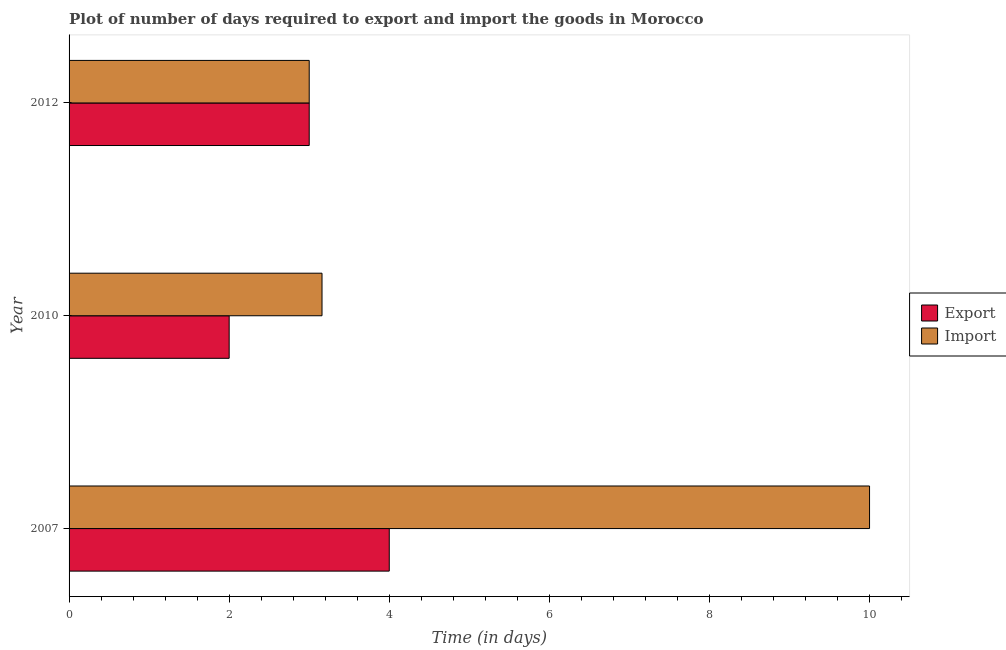Are the number of bars per tick equal to the number of legend labels?
Offer a very short reply. Yes. Are the number of bars on each tick of the Y-axis equal?
Offer a very short reply. Yes. How many bars are there on the 1st tick from the top?
Ensure brevity in your answer.  2. How many bars are there on the 2nd tick from the bottom?
Offer a terse response. 2. What is the time required to import in 2010?
Ensure brevity in your answer.  3.16. What is the total time required to import in the graph?
Give a very brief answer. 16.16. What is the difference between the time required to import in 2010 and that in 2012?
Ensure brevity in your answer.  0.16. What is the difference between the time required to import in 2010 and the time required to export in 2007?
Your answer should be compact. -0.84. What is the average time required to import per year?
Offer a very short reply. 5.39. In the year 2010, what is the difference between the time required to import and time required to export?
Offer a terse response. 1.16. What is the ratio of the time required to export in 2007 to that in 2012?
Keep it short and to the point. 1.33. Is the difference between the time required to import in 2010 and 2012 greater than the difference between the time required to export in 2010 and 2012?
Make the answer very short. Yes. What is the difference between the highest and the second highest time required to import?
Give a very brief answer. 6.84. What is the difference between the highest and the lowest time required to export?
Keep it short and to the point. 2. Is the sum of the time required to import in 2007 and 2010 greater than the maximum time required to export across all years?
Give a very brief answer. Yes. What does the 2nd bar from the top in 2010 represents?
Offer a terse response. Export. What does the 2nd bar from the bottom in 2010 represents?
Offer a terse response. Import. How many bars are there?
Give a very brief answer. 6. Are all the bars in the graph horizontal?
Ensure brevity in your answer.  Yes. How many years are there in the graph?
Provide a succinct answer. 3. Does the graph contain grids?
Keep it short and to the point. No. What is the title of the graph?
Ensure brevity in your answer.  Plot of number of days required to export and import the goods in Morocco. Does "current US$" appear as one of the legend labels in the graph?
Keep it short and to the point. No. What is the label or title of the X-axis?
Keep it short and to the point. Time (in days). What is the Time (in days) in Import in 2010?
Ensure brevity in your answer.  3.16. What is the Time (in days) in Import in 2012?
Your answer should be very brief. 3. Across all years, what is the maximum Time (in days) in Export?
Your response must be concise. 4. Across all years, what is the maximum Time (in days) of Import?
Keep it short and to the point. 10. Across all years, what is the minimum Time (in days) of Export?
Offer a terse response. 2. What is the total Time (in days) of Import in the graph?
Provide a short and direct response. 16.16. What is the difference between the Time (in days) in Import in 2007 and that in 2010?
Your answer should be compact. 6.84. What is the difference between the Time (in days) of Export in 2007 and that in 2012?
Your answer should be very brief. 1. What is the difference between the Time (in days) in Import in 2010 and that in 2012?
Keep it short and to the point. 0.16. What is the difference between the Time (in days) of Export in 2007 and the Time (in days) of Import in 2010?
Provide a succinct answer. 0.84. What is the difference between the Time (in days) in Export in 2007 and the Time (in days) in Import in 2012?
Ensure brevity in your answer.  1. What is the average Time (in days) of Export per year?
Make the answer very short. 3. What is the average Time (in days) of Import per year?
Make the answer very short. 5.39. In the year 2007, what is the difference between the Time (in days) of Export and Time (in days) of Import?
Make the answer very short. -6. In the year 2010, what is the difference between the Time (in days) of Export and Time (in days) of Import?
Offer a terse response. -1.16. What is the ratio of the Time (in days) in Export in 2007 to that in 2010?
Provide a succinct answer. 2. What is the ratio of the Time (in days) of Import in 2007 to that in 2010?
Offer a very short reply. 3.16. What is the ratio of the Time (in days) of Export in 2007 to that in 2012?
Give a very brief answer. 1.33. What is the ratio of the Time (in days) of Import in 2010 to that in 2012?
Make the answer very short. 1.05. What is the difference between the highest and the second highest Time (in days) of Import?
Your answer should be compact. 6.84. What is the difference between the highest and the lowest Time (in days) of Export?
Your answer should be compact. 2. What is the difference between the highest and the lowest Time (in days) in Import?
Keep it short and to the point. 7. 